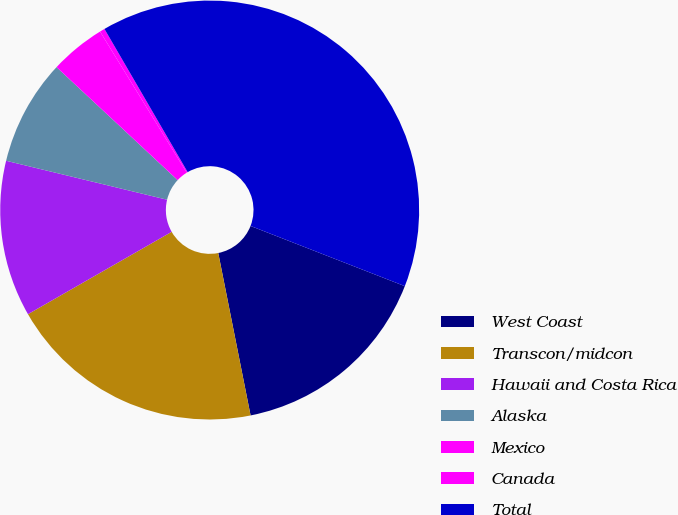Convert chart to OTSL. <chart><loc_0><loc_0><loc_500><loc_500><pie_chart><fcel>West Coast<fcel>Transcon/midcon<fcel>Hawaii and Costa Rica<fcel>Alaska<fcel>Mexico<fcel>Canada<fcel>Total<nl><fcel>15.95%<fcel>19.84%<fcel>12.06%<fcel>8.17%<fcel>4.28%<fcel>0.39%<fcel>39.29%<nl></chart> 